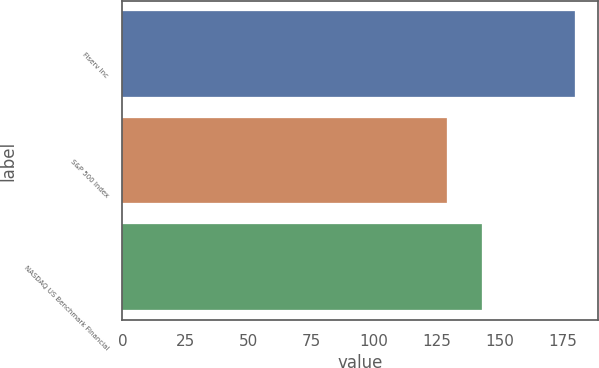<chart> <loc_0><loc_0><loc_500><loc_500><bar_chart><fcel>Fiserv Inc<fcel>S&P 500 Index<fcel>NASDAQ US Benchmark Financial<nl><fcel>180<fcel>129<fcel>143<nl></chart> 